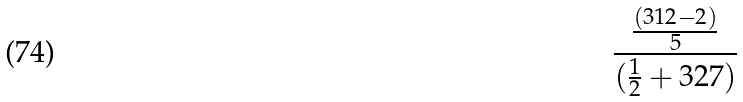<formula> <loc_0><loc_0><loc_500><loc_500>\frac { \frac { ( 3 1 2 - 2 ) } { 5 } } { ( \frac { 1 } { 2 } + 3 2 7 ) }</formula> 